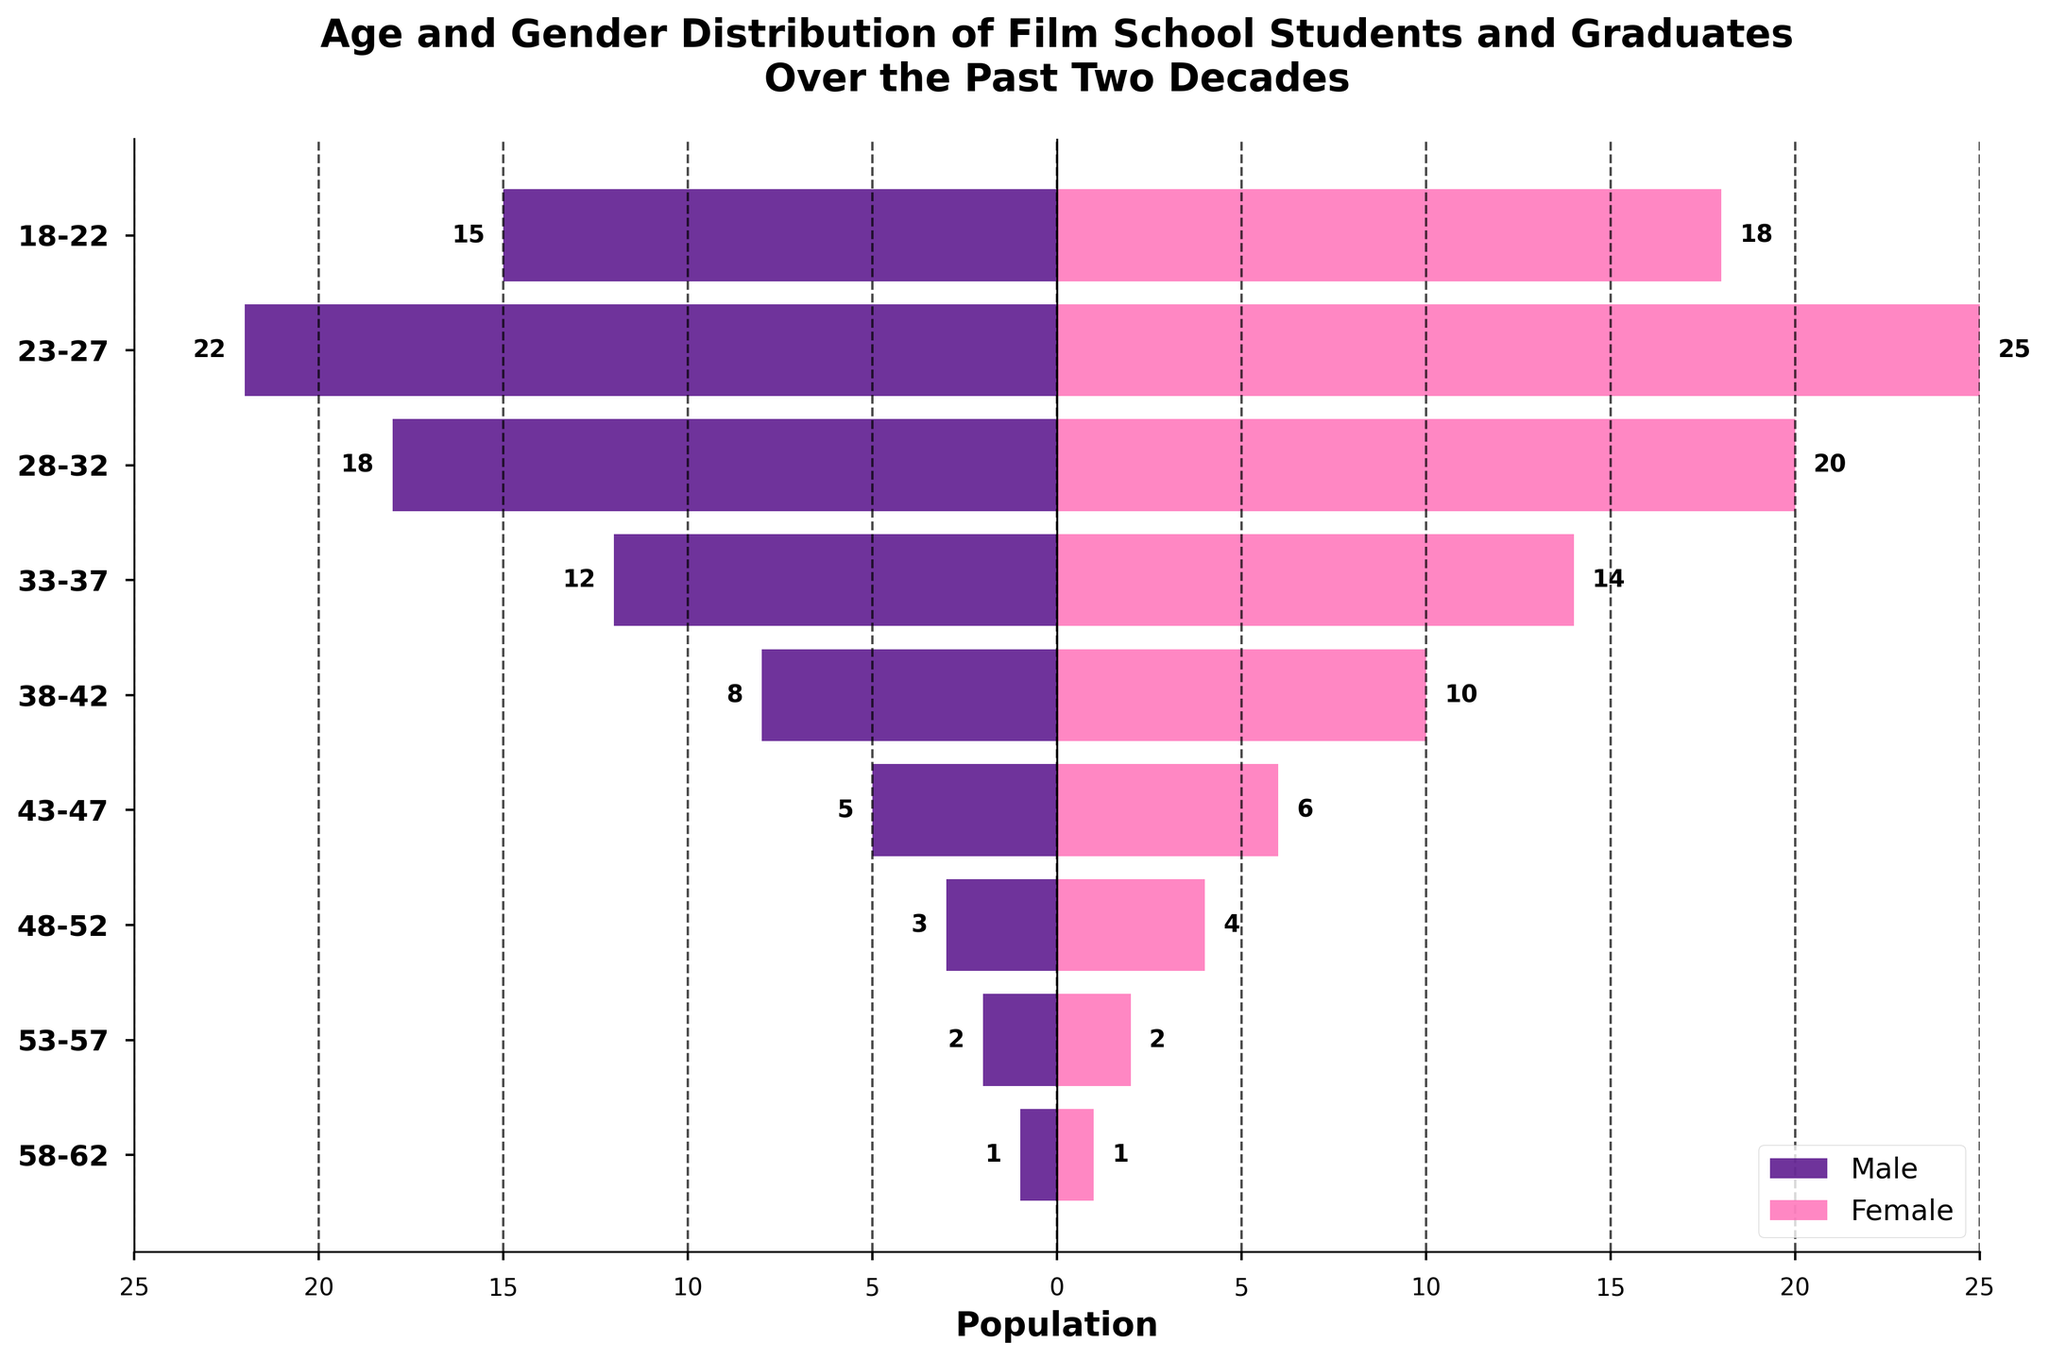What is the title of the figure? The title is located at the top of the figure and it states the main subject matter or purpose of the plot.
Answer: Age and Gender Distribution of Film School Students and Graduates Over the Past Two Decades Which age group has the largest number of females? By looking at the female bars for each age group and identifying which one is the longest, you can find the age group with the largest number of females.
Answer: 23-27 How many males and females are there in the age group 33-37? By locating the 33-37 age group and reading the values of the male and female bars, you get the respective counts.
Answer: Male: 12, Female: 14 How many more females are there than males in the age group 38-42? Subtract the number of males from the number of females in the age group 38-42. This involves looking at the respective bar lengths and labels.
Answer: 2 Which gender has a higher population in the age group 48-52 and by how much? Compare the male and female bars for the 48-52 age group and find the difference between their values.
Answer: Female by 1 What is the total number of males across all age groups? Sum the number of males in each age group by reading off the values of the male bars and adding them up. The calculation is 15 + 22 + 18 + 12 + 8 + 5 + 3 + 2 + 1 = 86.
Answer: 86 What is the average number of females in the 23-27 and 28-32 age groups? Add the number of females in the 23-27 and 28-32 age groups and then divide by 2. The calculation is (25 + 20) / 2 = 22.5.
Answer: 22.5 Is there any age group where the number of males and females is the same? Compare the male and female bars for each age group and identify if there is any age group where the values are equal.
Answer: 58-62 and 53-57 Which age group has the smallest combined population of males and females? Add the number of males and females for each age group and identify the group with the smallest sum. The calculation shows age group 58-62 has 1 male and 1 female, so 1 + 1 = 2.
Answer: 58-62 